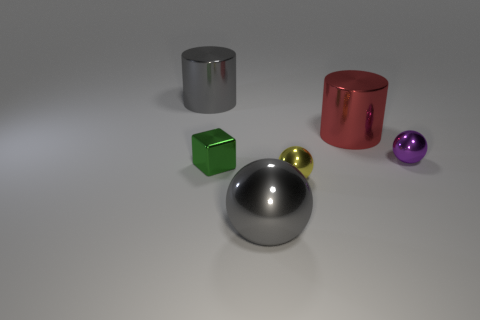Add 3 yellow objects. How many objects exist? 9 Subtract all cubes. How many objects are left? 5 Add 6 large gray metal spheres. How many large gray metal spheres exist? 7 Subtract 0 green balls. How many objects are left? 6 Subtract all cylinders. Subtract all big red matte blocks. How many objects are left? 4 Add 3 metallic objects. How many metallic objects are left? 9 